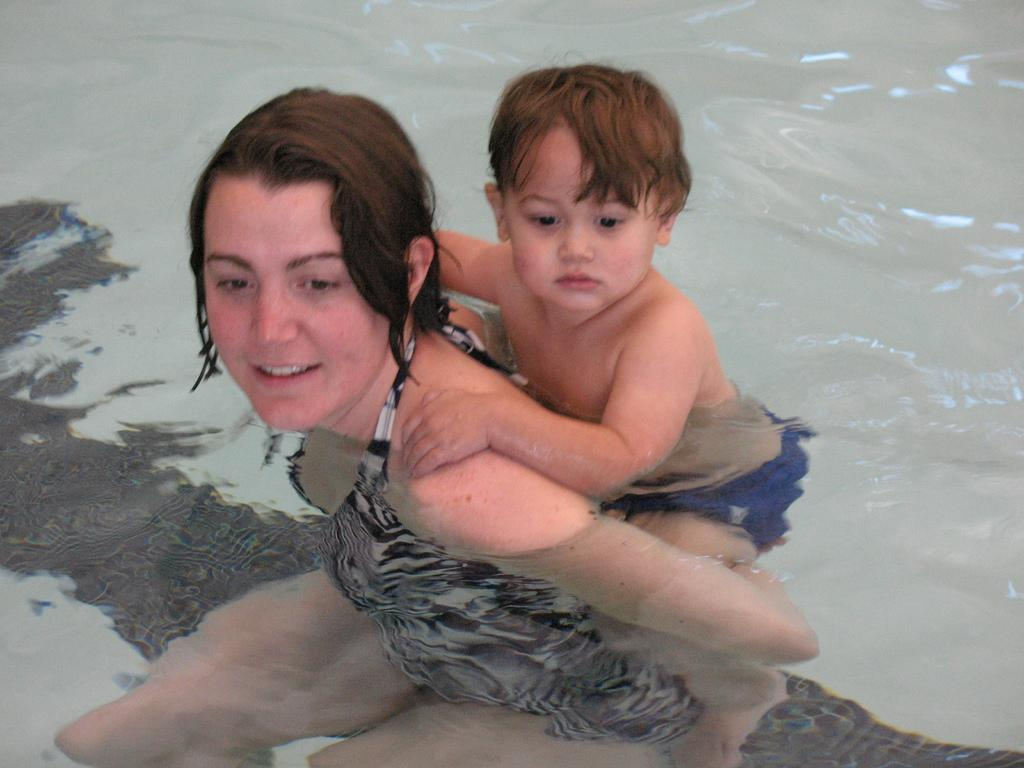Who is present in the image? There is a woman and a kid in the image. What are the woman and the kid doing in the image? The woman and the kid are present in the water. What type of rake is the woman using to gather the flesh in the image? There is no rake or flesh present in the image; it features a woman and a kid in the water. 